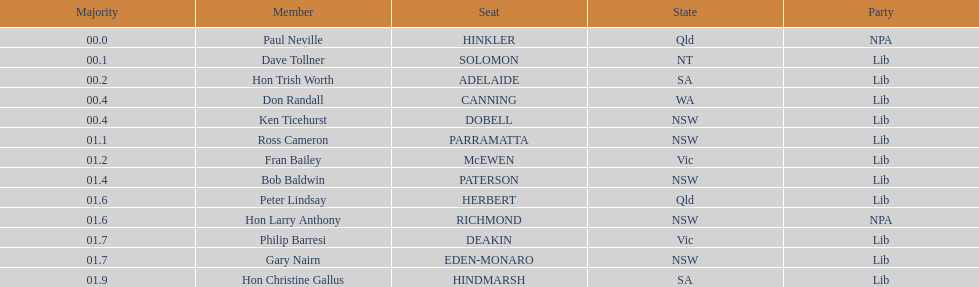Was fran bailey from vic or wa? Vic. 